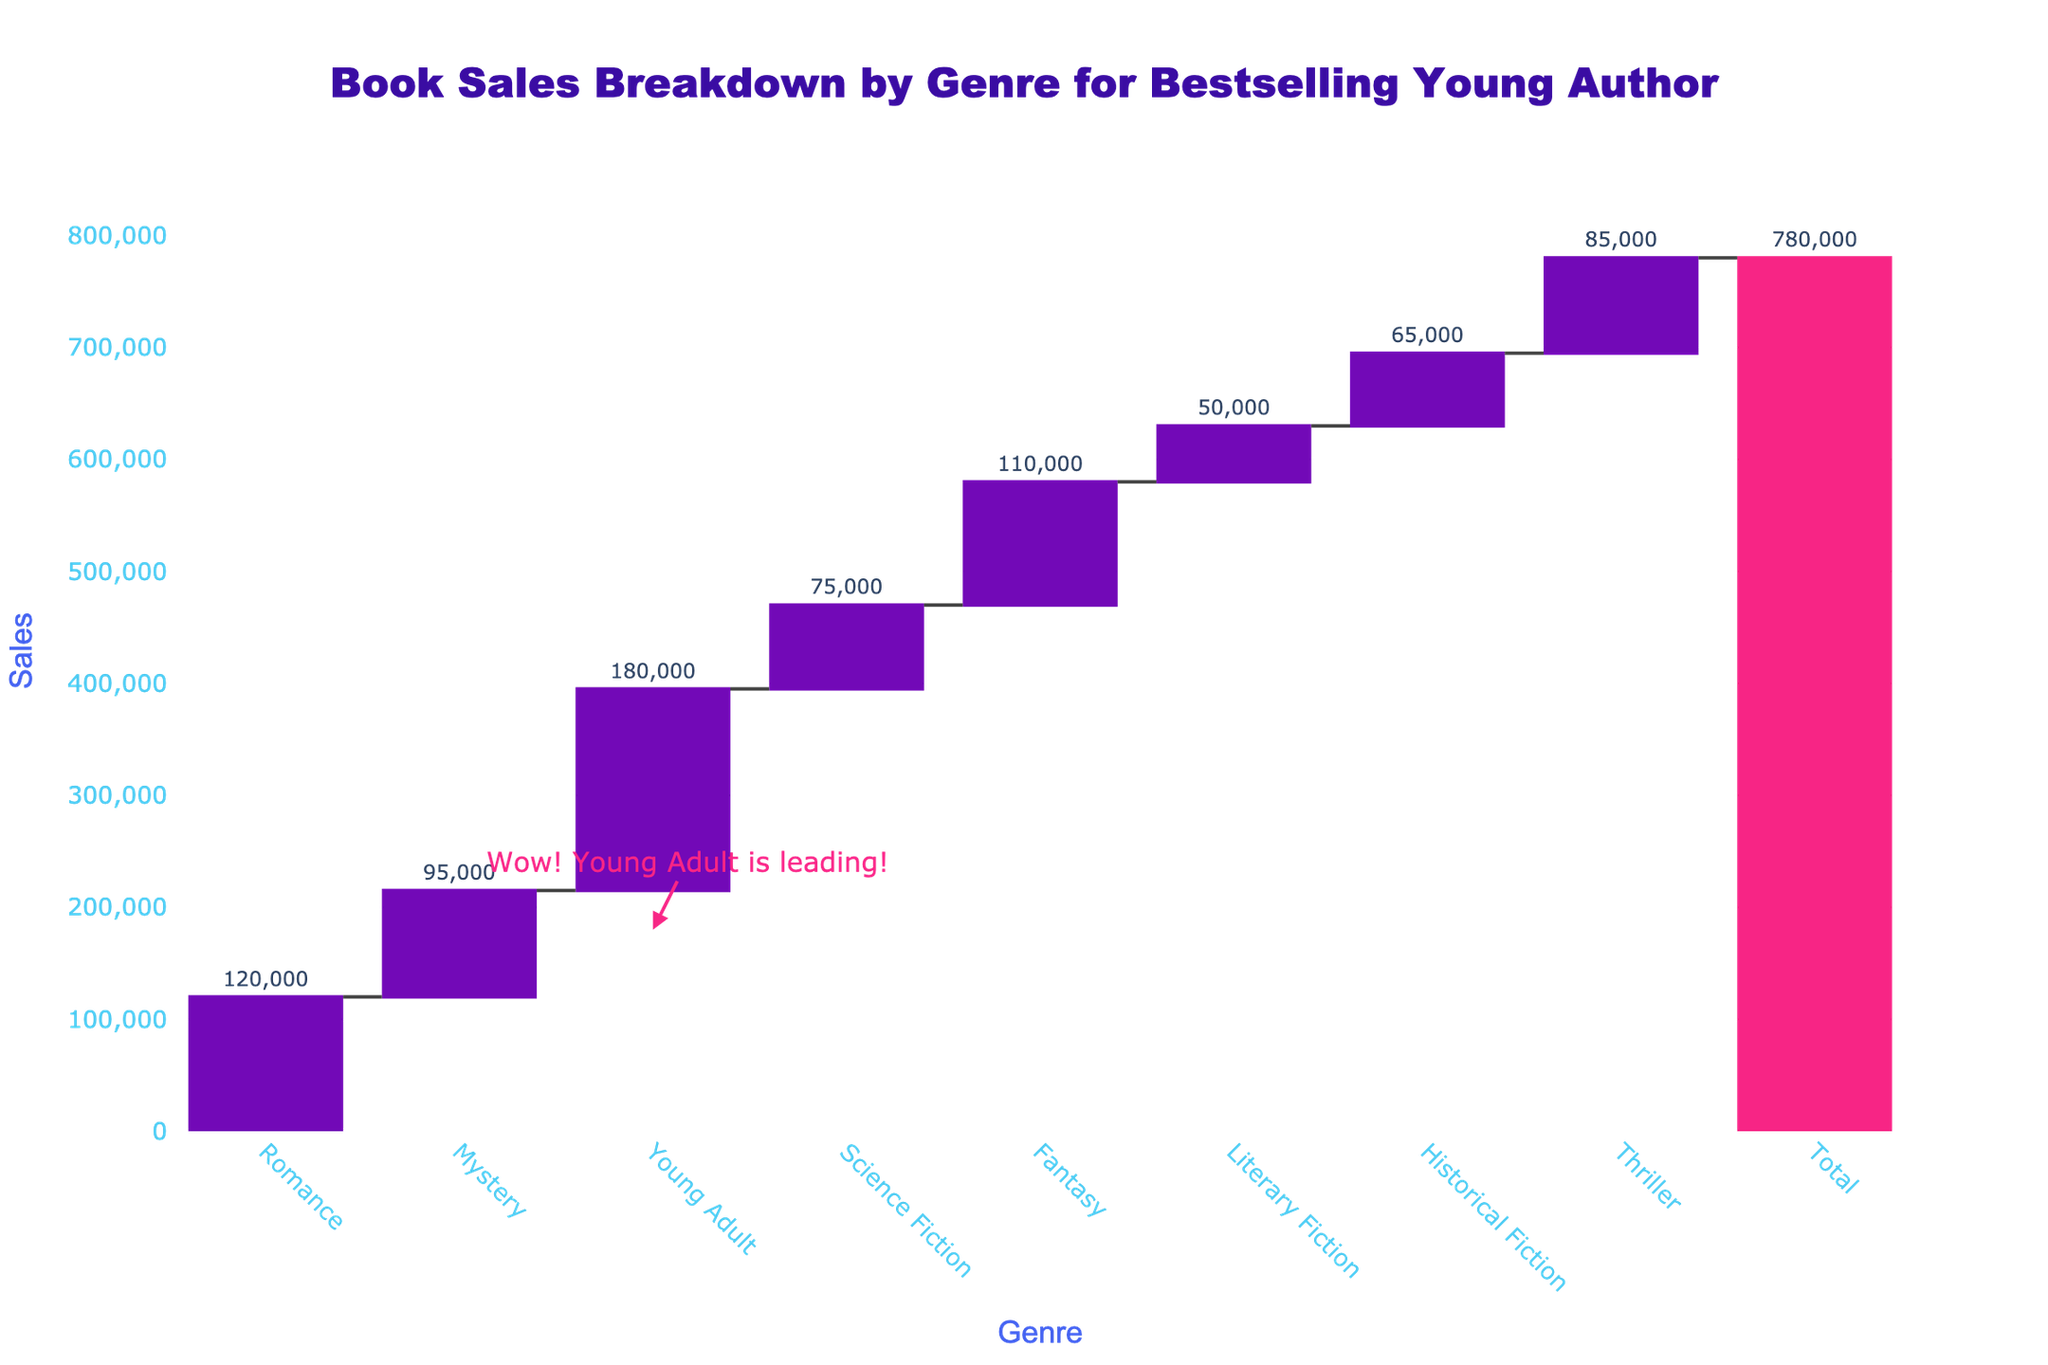what is the total number of book sales? Look at the "Total" bar at the end of the waterfall chart, which sums up all individual genre sales. The text on the "Total" bar indicates the total sales.
Answer: 780,000 which genre had the highest sales? Check the length of the bars in the chart to find the longest one, and read its genre label. The "Young Adult" genre has the highest sales, as indicated by both the text above the bar (180,000) and an annotation highlighting it.
Answer: Young Adult how much more did Fantasy genre sell compared to Science Fiction? Identify the sales figures for both genres: Fantasy (110,000) and Science Fiction (75,000). Subtract the lower sales from the higher sales to find the difference. 110,000 - 75,000 = 35,000.
Answer: 35,000 which genre sold the least, and how many copies were sold? Look for the shortest bar in the waterfall chart and note its label and the text indicating the sales number. The "Literary Fiction" bar is the shortest, with sales of 50,000.
Answer: Literary Fiction, 50,000 what is the average sales amount for all individual genres? Sum up the sales of all individual genres and divide by the number of genres. Sum: 120,000 + 95,000 + 180,000 + 75,000 + 110,000 + 50,000 + 65,000 + 85,000 = 780,000. Number of genres: 8. Average: 780,000 / 8 = 97,500.
Answer: 97,500 did Mystery genre sell more than Thriller genre? Compare the sales figures for Mystery (95,000) and Thriller (85,000). Since 95,000 is greater than 85,000, Mystery sold more than Thriller.
Answer: Yes what is the combined sales of Romance and Fantasy genres? Add the sales figures for Romance (120,000) and Fantasy (110,000). 120,000 + 110,000 = 230,000.
Answer: 230,000 which two genres have sales closest to each other? Compare sales values and find the smallest difference. The closest numbers are Mystery (95,000) and Thriller (85,000), with a difference of 10,000.
Answer: Mystery and Thriller what percentage of the total sales is contributed by the Romance genre? Calculate the contribution of Romance sales to the total. (Sales of Romance / Total Sales) * 100 = (120,000 / 780,000) * 100 ≈ 15.38%.
Answer: ~15.38% how many genres sold more than 100,000 copies? Count the bars with sales figures exceeding 100,000. The genres are Romance (120,000), Young Adult (180,000), Fantasy (110,000). That's three genres.
Answer: 3 